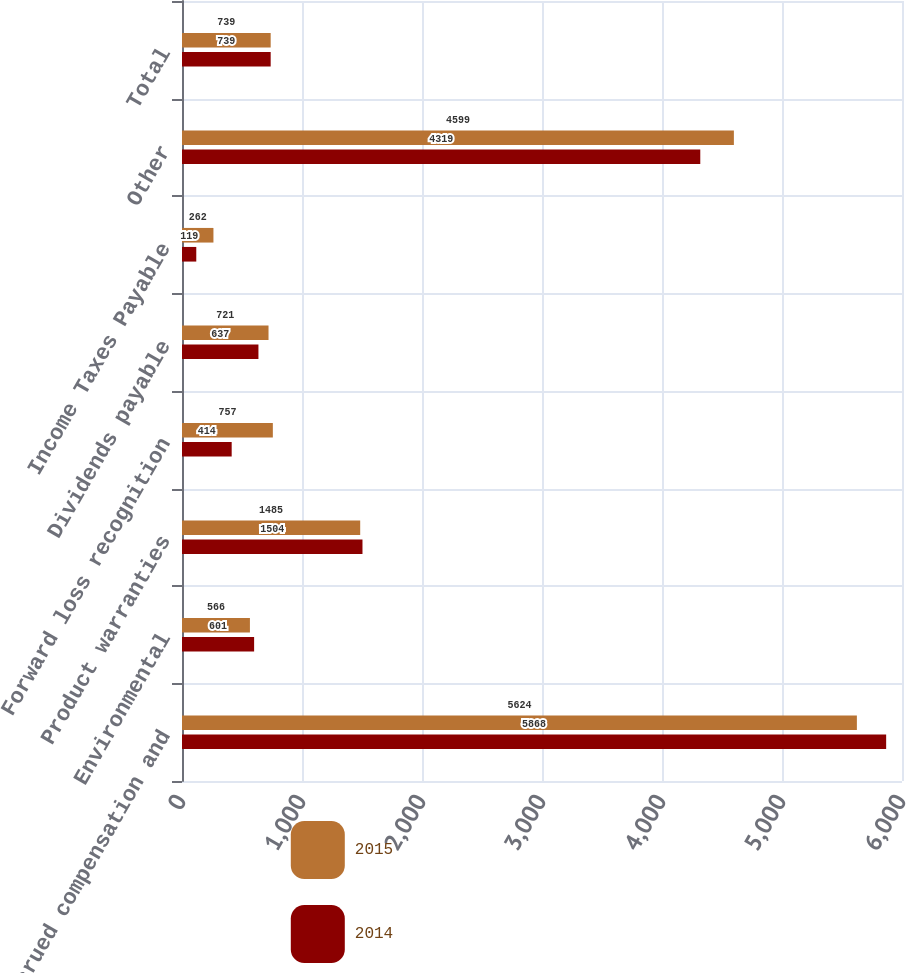Convert chart. <chart><loc_0><loc_0><loc_500><loc_500><stacked_bar_chart><ecel><fcel>Accrued compensation and<fcel>Environmental<fcel>Product warranties<fcel>Forward loss recognition<fcel>Dividends payable<fcel>Income Taxes Payable<fcel>Other<fcel>Total<nl><fcel>2015<fcel>5624<fcel>566<fcel>1485<fcel>757<fcel>721<fcel>262<fcel>4599<fcel>739<nl><fcel>2014<fcel>5868<fcel>601<fcel>1504<fcel>414<fcel>637<fcel>119<fcel>4319<fcel>739<nl></chart> 